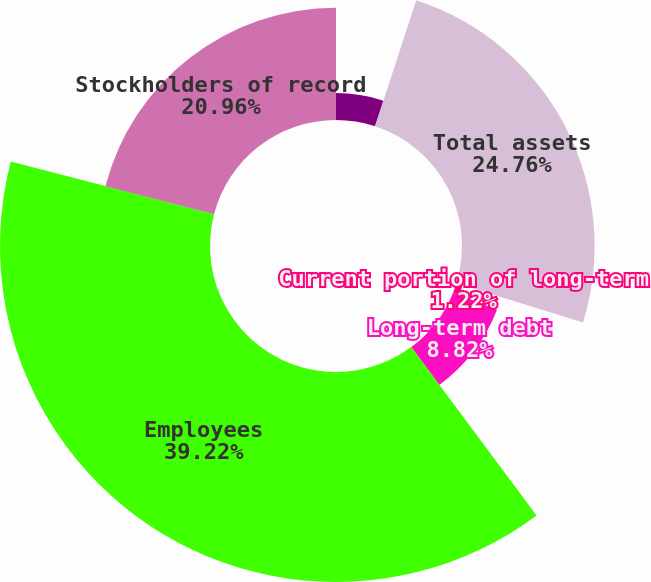Convert chart to OTSL. <chart><loc_0><loc_0><loc_500><loc_500><pie_chart><fcel>Cash cash equivalents and<fcel>Total assets<fcel>Current portion of long-term<fcel>Long-term debt<fcel>Employees<fcel>Stockholders of record<nl><fcel>5.02%<fcel>24.76%<fcel>1.22%<fcel>8.82%<fcel>39.22%<fcel>20.96%<nl></chart> 